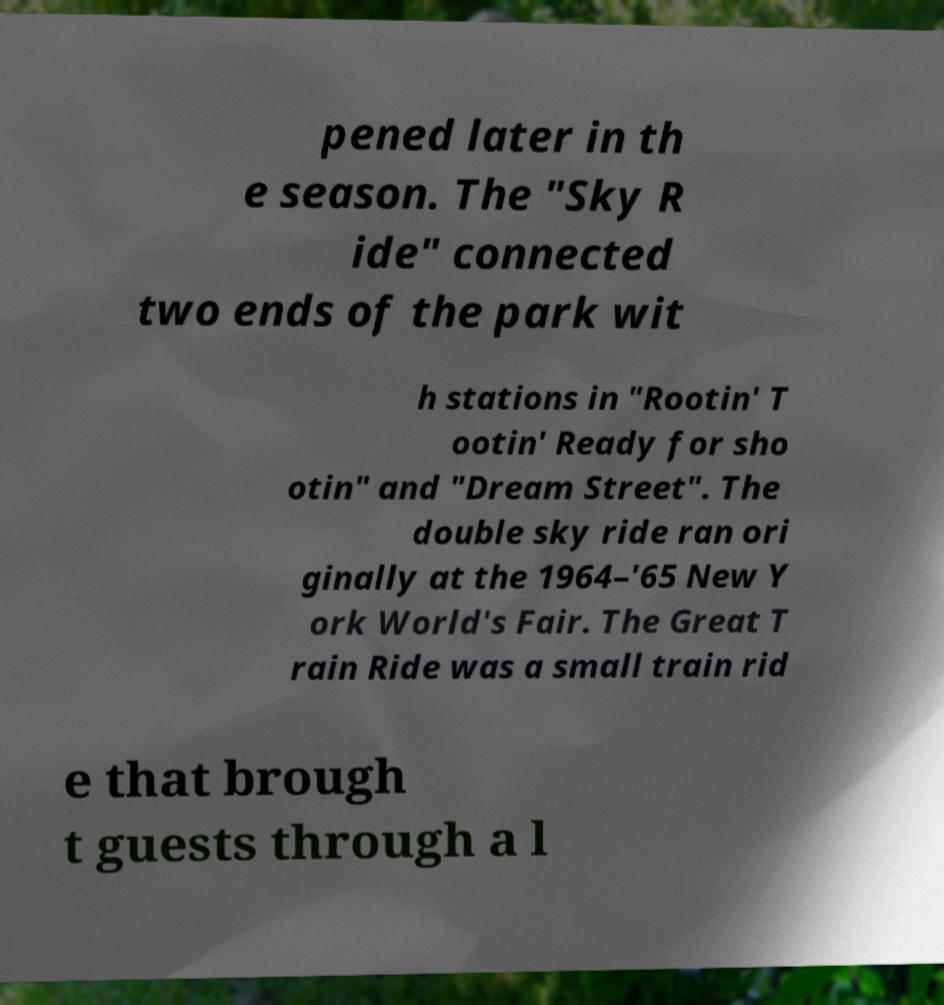For documentation purposes, I need the text within this image transcribed. Could you provide that? pened later in th e season. The "Sky R ide" connected two ends of the park wit h stations in "Rootin' T ootin' Ready for sho otin" and "Dream Street". The double sky ride ran ori ginally at the 1964–'65 New Y ork World's Fair. The Great T rain Ride was a small train rid e that brough t guests through a l 